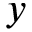<formula> <loc_0><loc_0><loc_500><loc_500>y</formula> 